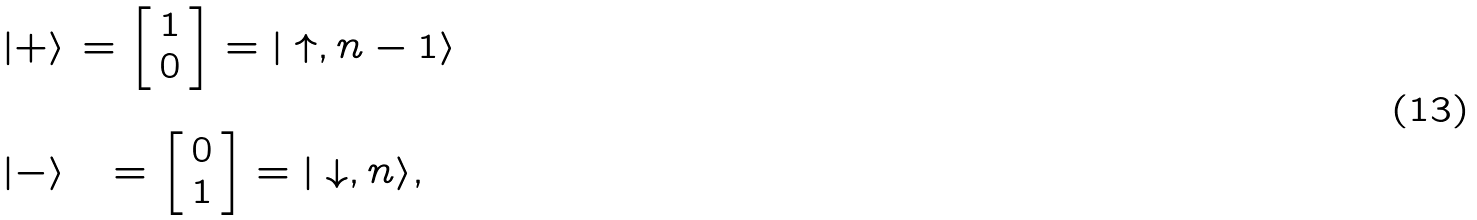Convert formula to latex. <formula><loc_0><loc_0><loc_500><loc_500>\begin{array} { c c } | + \rangle & = \left [ \begin{array} { c } 1 \\ 0 \end{array} \right ] = | \uparrow , n - 1 \rangle \\ \\ | - \rangle & = \left [ \begin{array} { c } 0 \\ 1 \end{array} \right ] = | \downarrow , n \rangle , \end{array}</formula> 